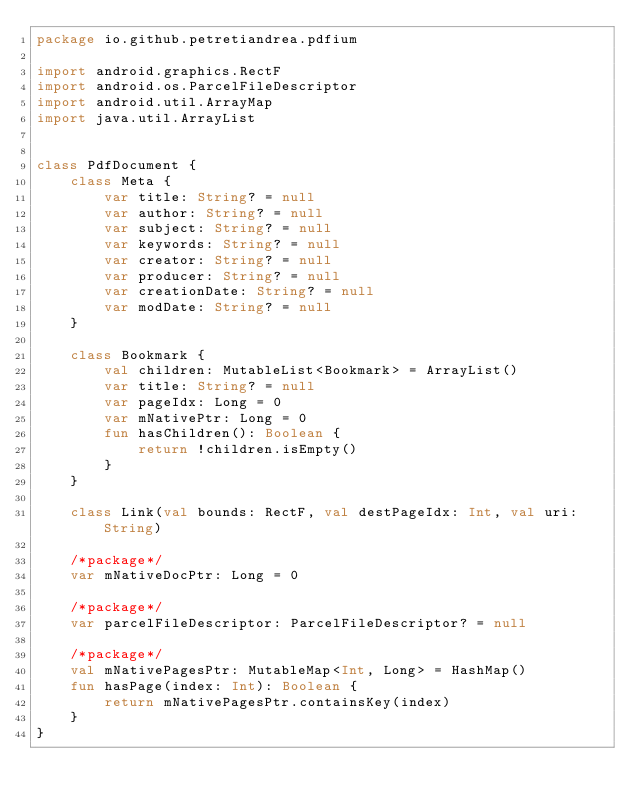Convert code to text. <code><loc_0><loc_0><loc_500><loc_500><_Kotlin_>package io.github.petretiandrea.pdfium

import android.graphics.RectF
import android.os.ParcelFileDescriptor
import android.util.ArrayMap
import java.util.ArrayList


class PdfDocument {
    class Meta {
        var title: String? = null
        var author: String? = null
        var subject: String? = null
        var keywords: String? = null
        var creator: String? = null
        var producer: String? = null
        var creationDate: String? = null
        var modDate: String? = null
    }

    class Bookmark {
        val children: MutableList<Bookmark> = ArrayList()
        var title: String? = null
        var pageIdx: Long = 0
        var mNativePtr: Long = 0
        fun hasChildren(): Boolean {
            return !children.isEmpty()
        }
    }

    class Link(val bounds: RectF, val destPageIdx: Int, val uri: String)

    /*package*/
    var mNativeDocPtr: Long = 0

    /*package*/
    var parcelFileDescriptor: ParcelFileDescriptor? = null

    /*package*/
    val mNativePagesPtr: MutableMap<Int, Long> = HashMap()
    fun hasPage(index: Int): Boolean {
        return mNativePagesPtr.containsKey(index)
    }
}</code> 